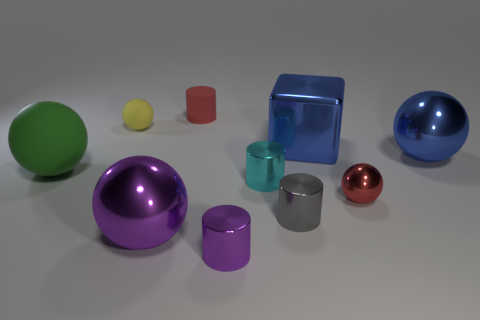What is the size of the purple object on the right side of the purple thing that is to the left of the tiny red object behind the small cyan metal cylinder? The purple object on the right side, which is a purple sphere, is approximately medium-sized compared to other objects in the image. It is behind the small cyan metal cylinder and to the right of another purple object which appears to be a cylindrical container. 